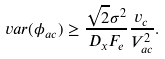Convert formula to latex. <formula><loc_0><loc_0><loc_500><loc_500>v a r ( \phi _ { a c } ) \geq \frac { \sqrt { 2 } \sigma ^ { 2 } } { D _ { x } F _ { e } } \frac { v _ { c } } { V _ { a c } ^ { 2 } } .</formula> 